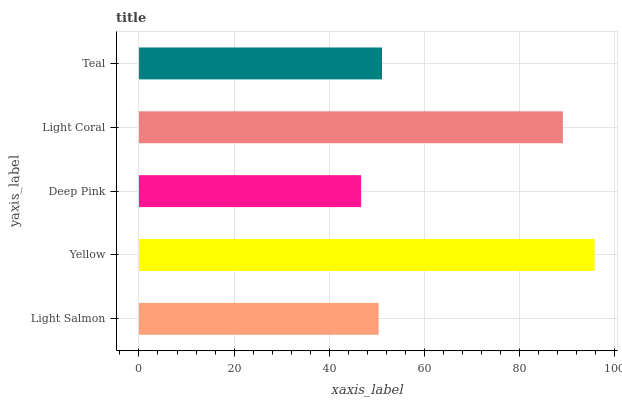Is Deep Pink the minimum?
Answer yes or no. Yes. Is Yellow the maximum?
Answer yes or no. Yes. Is Yellow the minimum?
Answer yes or no. No. Is Deep Pink the maximum?
Answer yes or no. No. Is Yellow greater than Deep Pink?
Answer yes or no. Yes. Is Deep Pink less than Yellow?
Answer yes or no. Yes. Is Deep Pink greater than Yellow?
Answer yes or no. No. Is Yellow less than Deep Pink?
Answer yes or no. No. Is Teal the high median?
Answer yes or no. Yes. Is Teal the low median?
Answer yes or no. Yes. Is Yellow the high median?
Answer yes or no. No. Is Light Coral the low median?
Answer yes or no. No. 